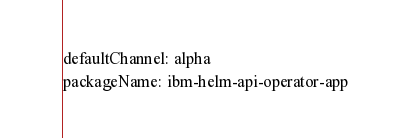Convert code to text. <code><loc_0><loc_0><loc_500><loc_500><_YAML_>defaultChannel: alpha
packageName: ibm-helm-api-operator-app
</code> 